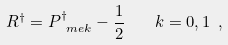<formula> <loc_0><loc_0><loc_500><loc_500>R ^ { \dag } = P _ { \ m e k } ^ { \dag } - \frac { 1 } { 2 } \quad k = 0 , 1 \ ,</formula> 